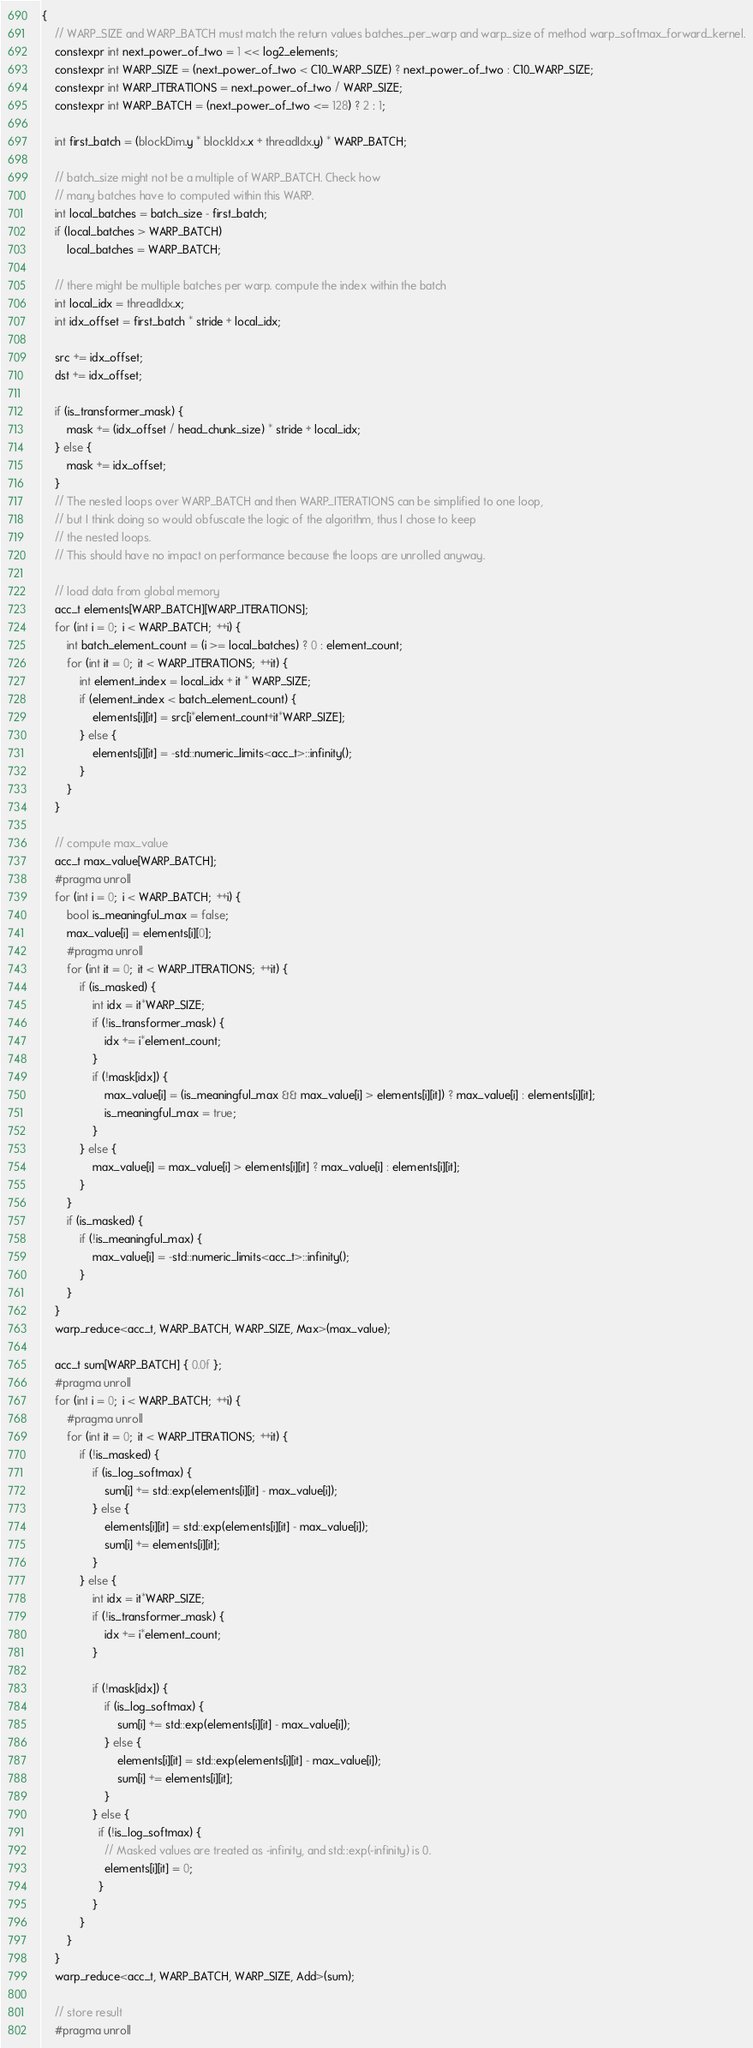<code> <loc_0><loc_0><loc_500><loc_500><_Cuda_>{
    // WARP_SIZE and WARP_BATCH must match the return values batches_per_warp and warp_size of method warp_softmax_forward_kernel.
    constexpr int next_power_of_two = 1 << log2_elements;
    constexpr int WARP_SIZE = (next_power_of_two < C10_WARP_SIZE) ? next_power_of_two : C10_WARP_SIZE;
    constexpr int WARP_ITERATIONS = next_power_of_two / WARP_SIZE;
    constexpr int WARP_BATCH = (next_power_of_two <= 128) ? 2 : 1;

    int first_batch = (blockDim.y * blockIdx.x + threadIdx.y) * WARP_BATCH;

    // batch_size might not be a multiple of WARP_BATCH. Check how
    // many batches have to computed within this WARP.
    int local_batches = batch_size - first_batch;
    if (local_batches > WARP_BATCH)
        local_batches = WARP_BATCH;

    // there might be multiple batches per warp. compute the index within the batch
    int local_idx = threadIdx.x;
    int idx_offset = first_batch * stride + local_idx;

    src += idx_offset;
    dst += idx_offset;

    if (is_transformer_mask) {
        mask += (idx_offset / head_chunk_size) * stride + local_idx;
    } else {
        mask += idx_offset;
    }
    // The nested loops over WARP_BATCH and then WARP_ITERATIONS can be simplified to one loop,
    // but I think doing so would obfuscate the logic of the algorithm, thus I chose to keep
    // the nested loops.
    // This should have no impact on performance because the loops are unrolled anyway.

    // load data from global memory
    acc_t elements[WARP_BATCH][WARP_ITERATIONS];
    for (int i = 0;  i < WARP_BATCH;  ++i) {
        int batch_element_count = (i >= local_batches) ? 0 : element_count;
        for (int it = 0;  it < WARP_ITERATIONS;  ++it) {
            int element_index = local_idx + it * WARP_SIZE;
            if (element_index < batch_element_count) {
                elements[i][it] = src[i*element_count+it*WARP_SIZE];
            } else {
                elements[i][it] = -std::numeric_limits<acc_t>::infinity();
            }
        }
    }

    // compute max_value
    acc_t max_value[WARP_BATCH];
    #pragma unroll
    for (int i = 0;  i < WARP_BATCH;  ++i) {
        bool is_meaningful_max = false;
        max_value[i] = elements[i][0];
        #pragma unroll
        for (int it = 0;  it < WARP_ITERATIONS;  ++it) {
            if (is_masked) {
                int idx = it*WARP_SIZE;
                if (!is_transformer_mask) {
                    idx += i*element_count;
                }
                if (!mask[idx]) {
                    max_value[i] = (is_meaningful_max && max_value[i] > elements[i][it]) ? max_value[i] : elements[i][it];
                    is_meaningful_max = true;
                }
            } else {
                max_value[i] = max_value[i] > elements[i][it] ? max_value[i] : elements[i][it];
            }
        }
        if (is_masked) {
            if (!is_meaningful_max) {
                max_value[i] = -std::numeric_limits<acc_t>::infinity();
            }
        }
    }
    warp_reduce<acc_t, WARP_BATCH, WARP_SIZE, Max>(max_value);

    acc_t sum[WARP_BATCH] { 0.0f };
    #pragma unroll
    for (int i = 0;  i < WARP_BATCH;  ++i) {
        #pragma unroll
        for (int it = 0;  it < WARP_ITERATIONS;  ++it) {
            if (!is_masked) {
                if (is_log_softmax) {
                    sum[i] += std::exp(elements[i][it] - max_value[i]);
                } else {
                    elements[i][it] = std::exp(elements[i][it] - max_value[i]);
                    sum[i] += elements[i][it];
                }
            } else {
                int idx = it*WARP_SIZE;
                if (!is_transformer_mask) {
                    idx += i*element_count;
                }

                if (!mask[idx]) {
                    if (is_log_softmax) {
                        sum[i] += std::exp(elements[i][it] - max_value[i]);
                    } else {
                        elements[i][it] = std::exp(elements[i][it] - max_value[i]);
                        sum[i] += elements[i][it];
                    }
                } else {
                  if (!is_log_softmax) {
                    // Masked values are treated as -infinity, and std::exp(-infinity) is 0.
                    elements[i][it] = 0;
                  }
                }
            }
        }
    }
    warp_reduce<acc_t, WARP_BATCH, WARP_SIZE, Add>(sum);

    // store result
    #pragma unroll</code> 